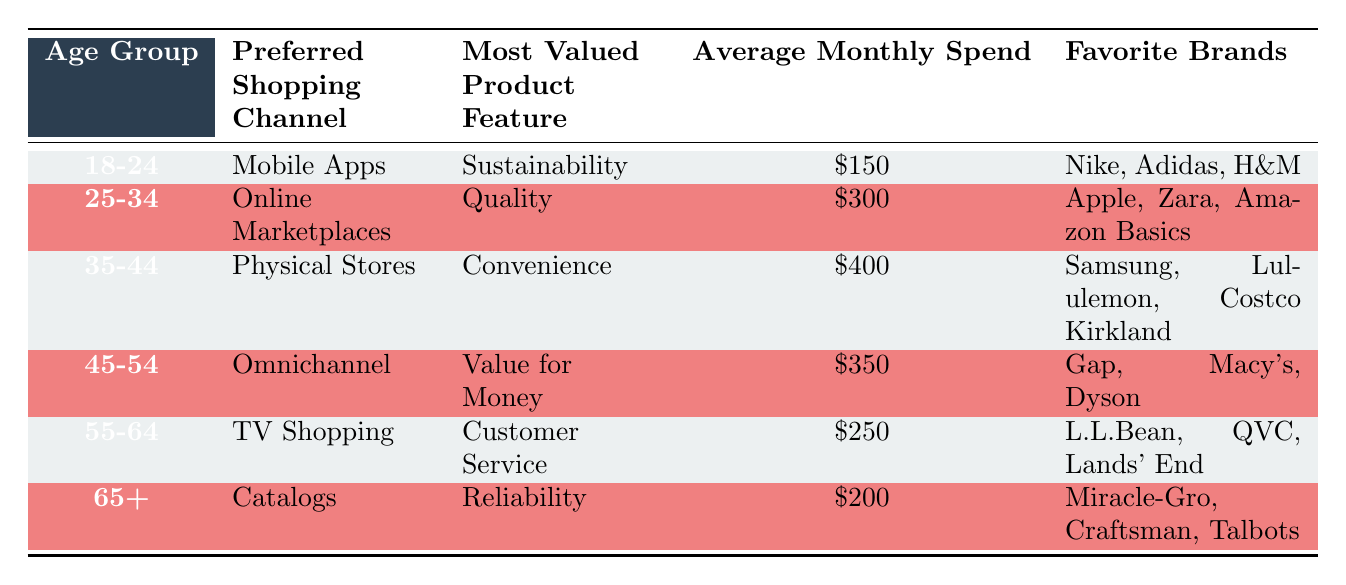What is the preferred shopping channel for the 18-24 age group? The table indicates that the preferred shopping channel for the 18-24 age group is "Mobile Apps."
Answer: Mobile Apps Which age group has the highest average monthly spend? By comparing the "Average Monthly Spend" values across all age groups, 35-44 has the highest spend at $400.
Answer: 35-44 Is "Quality" the most valued product feature for the 45-54 age group? The table shows that the most valued product feature for the 45-54 age group is "Value for Money," not "Quality."
Answer: No What is the total average monthly spend for the 55-64 and 65+ age groups combined? The average monthly spends are $250 for 55-64 and $200 for 65+. Their sum is 250 + 200 = 450.
Answer: $450 Which age group favors "Online Marketplaces" and what is their average monthly spend? The table specifies that the 25-34 age group favors "Online Marketplaces" and their average monthly spend is $300.
Answer: 25-34, $300 Are any age groups listed as having a favorite brand of "Dyson"? Yes, the age group 45-54 lists "Dyson" as one of their favorite brands.
Answer: Yes What is the difference in average monthly spend between the 35-44 and 55-64 age groups? The average monthly spend for 35-44 is $400 and for 55-64 is $250. The difference is 400 - 250 = 150.
Answer: $150 For which age group is "Reliability" the most valued product feature? The 65+ age group values "Reliability" as their most valued product feature according to the table.
Answer: 65+ Which age group prefers "Physical Stores" and what are their favorite brands? The 35-44 age group prefers "Physical Stores," and their favorite brands are Samsung, Lululemon, and Costco Kirkland.
Answer: 35-44, Samsung, Lululemon, Costco Kirkland 